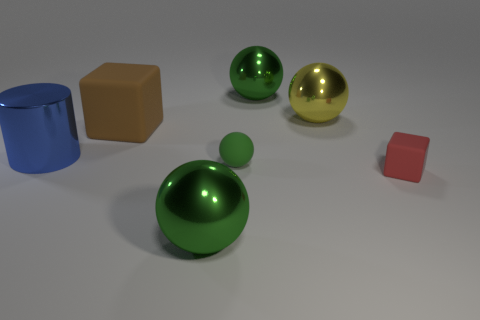How many green balls must be subtracted to get 1 green balls? 2 Subtract all small matte spheres. How many spheres are left? 3 Subtract all yellow balls. How many balls are left? 3 Add 3 small cyan rubber cubes. How many objects exist? 10 Subtract all cubes. How many objects are left? 5 Add 6 tiny green rubber objects. How many tiny green rubber objects are left? 7 Add 4 big blue objects. How many big blue objects exist? 5 Subtract 0 red spheres. How many objects are left? 7 Subtract 1 blocks. How many blocks are left? 1 Subtract all cyan cylinders. Subtract all gray balls. How many cylinders are left? 1 